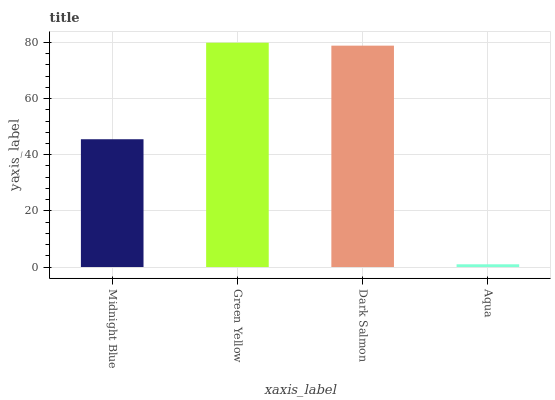Is Aqua the minimum?
Answer yes or no. Yes. Is Green Yellow the maximum?
Answer yes or no. Yes. Is Dark Salmon the minimum?
Answer yes or no. No. Is Dark Salmon the maximum?
Answer yes or no. No. Is Green Yellow greater than Dark Salmon?
Answer yes or no. Yes. Is Dark Salmon less than Green Yellow?
Answer yes or no. Yes. Is Dark Salmon greater than Green Yellow?
Answer yes or no. No. Is Green Yellow less than Dark Salmon?
Answer yes or no. No. Is Dark Salmon the high median?
Answer yes or no. Yes. Is Midnight Blue the low median?
Answer yes or no. Yes. Is Midnight Blue the high median?
Answer yes or no. No. Is Dark Salmon the low median?
Answer yes or no. No. 